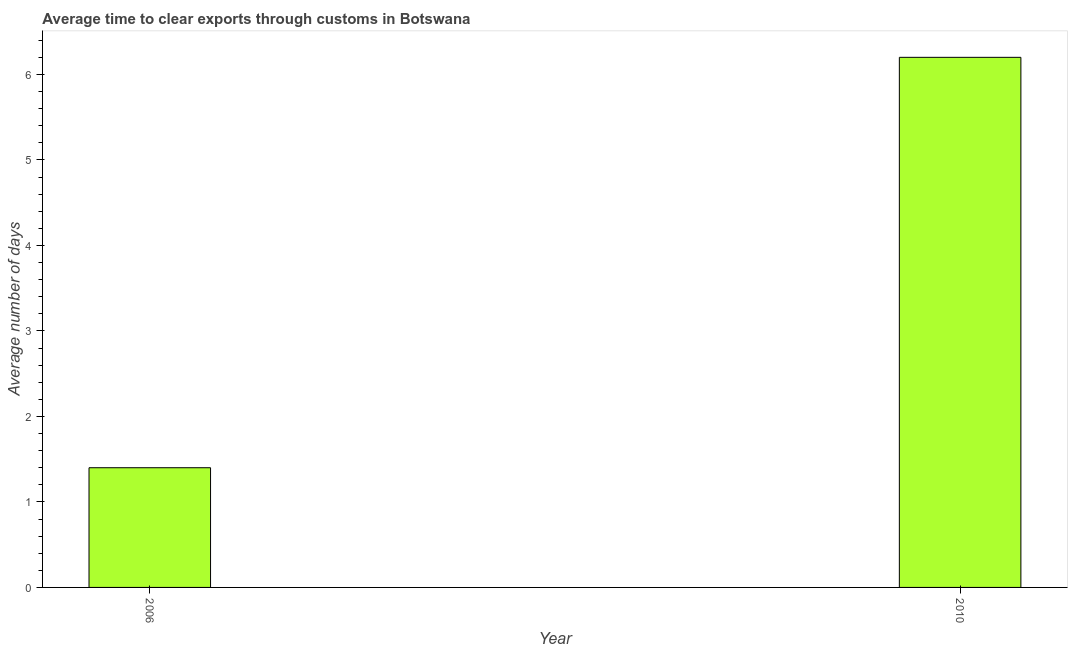Does the graph contain any zero values?
Make the answer very short. No. Does the graph contain grids?
Offer a terse response. No. What is the title of the graph?
Your answer should be compact. Average time to clear exports through customs in Botswana. What is the label or title of the Y-axis?
Keep it short and to the point. Average number of days. Across all years, what is the minimum time to clear exports through customs?
Provide a succinct answer. 1.4. What is the sum of the time to clear exports through customs?
Ensure brevity in your answer.  7.6. What is the median time to clear exports through customs?
Your answer should be compact. 3.8. In how many years, is the time to clear exports through customs greater than 6.2 days?
Give a very brief answer. 0. Do a majority of the years between 2006 and 2010 (inclusive) have time to clear exports through customs greater than 3.4 days?
Your response must be concise. No. What is the ratio of the time to clear exports through customs in 2006 to that in 2010?
Your answer should be compact. 0.23. Is the time to clear exports through customs in 2006 less than that in 2010?
Your answer should be very brief. Yes. How many bars are there?
Offer a very short reply. 2. How many years are there in the graph?
Offer a very short reply. 2. Are the values on the major ticks of Y-axis written in scientific E-notation?
Ensure brevity in your answer.  No. What is the Average number of days in 2006?
Your response must be concise. 1.4. What is the Average number of days of 2010?
Provide a succinct answer. 6.2. What is the ratio of the Average number of days in 2006 to that in 2010?
Provide a short and direct response. 0.23. 